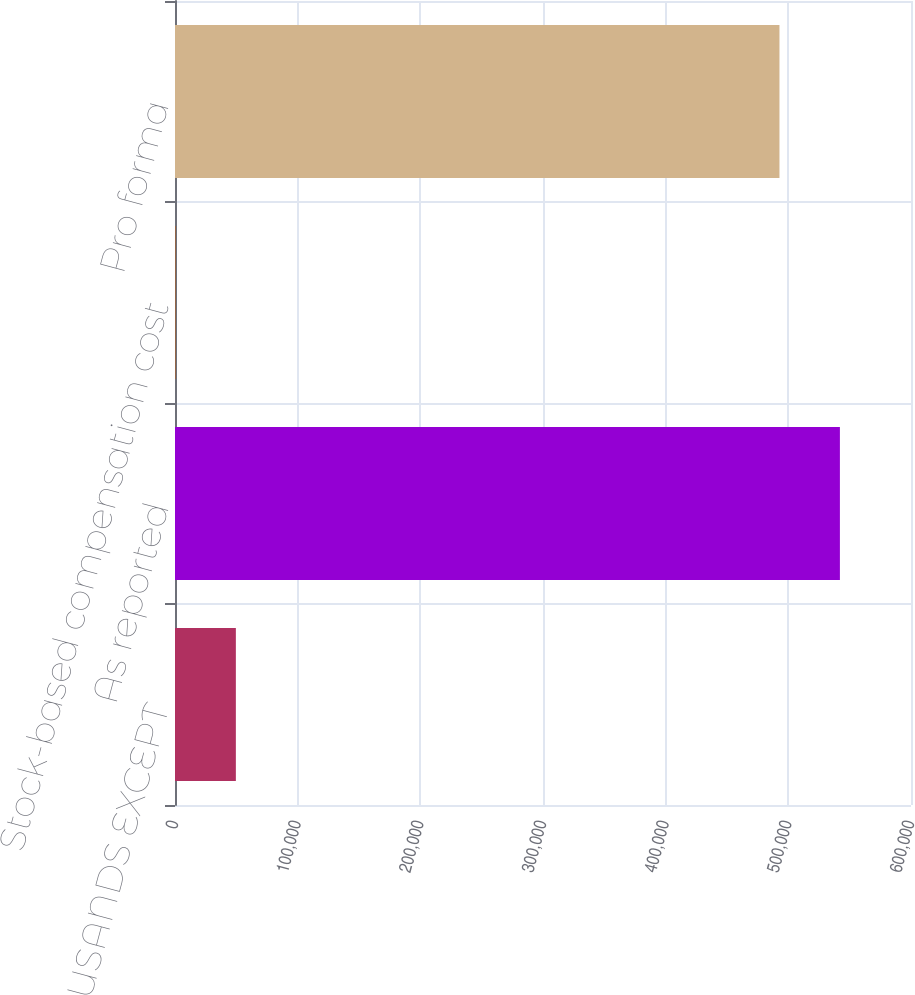Convert chart to OTSL. <chart><loc_0><loc_0><loc_500><loc_500><bar_chart><fcel>(AMOUNTS IN THOUSANDS EXCEPT<fcel>As reported<fcel>Stock-based compensation cost<fcel>Pro forma<nl><fcel>49613.6<fcel>542043<fcel>337<fcel>492766<nl></chart> 